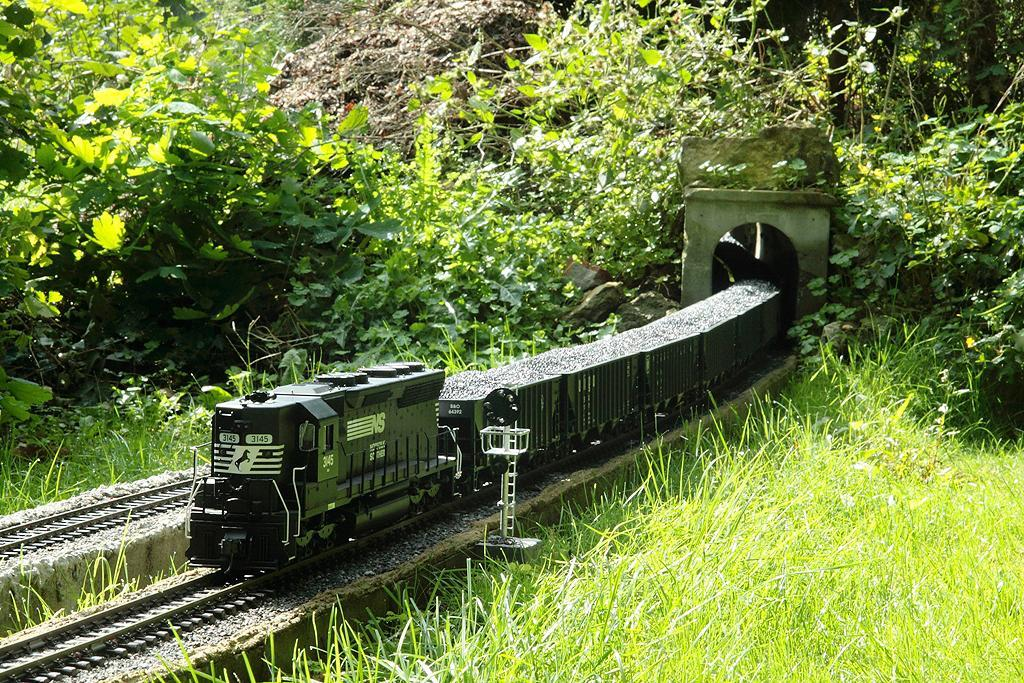What is the main subject of the image? There is a train in the image. Where is the train located? The train is on a track. What type of vegetation can be seen in the image? There is grass and plants visible in the image. What else is present in the image besides the train and vegetation? There is a pole in the image. How many coaches can be seen attached to the train in the image? There is no information about the number of coaches attached to the train in the image. What type of ant is crawling on the train in the image? There are no ants present in the image. 